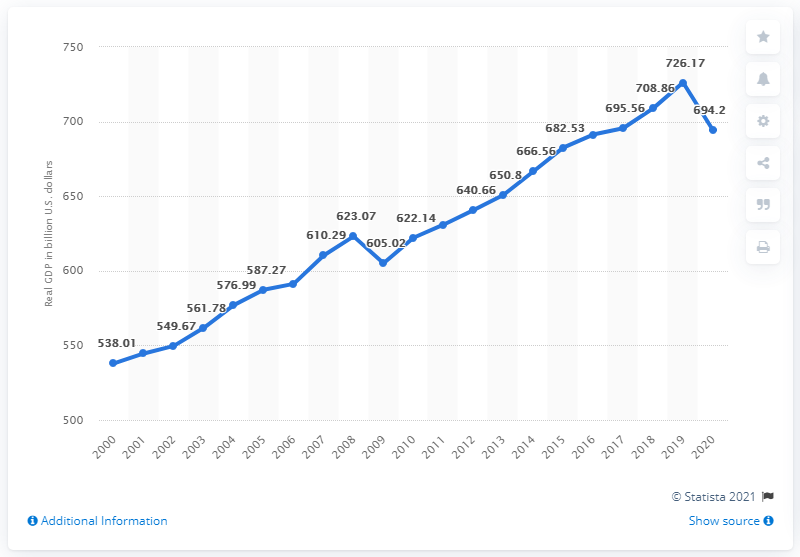Give some essential details in this illustration. In the previous year, the Gross Domestic Product (GDP) of Pennsylvania was 726.17 billion dollars. In 2020, the real GDP of Pennsylvania was 694.2 billion dollars. 